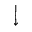<formula> <loc_0><loc_0><loc_500><loc_500>\Big \downarrow</formula> 